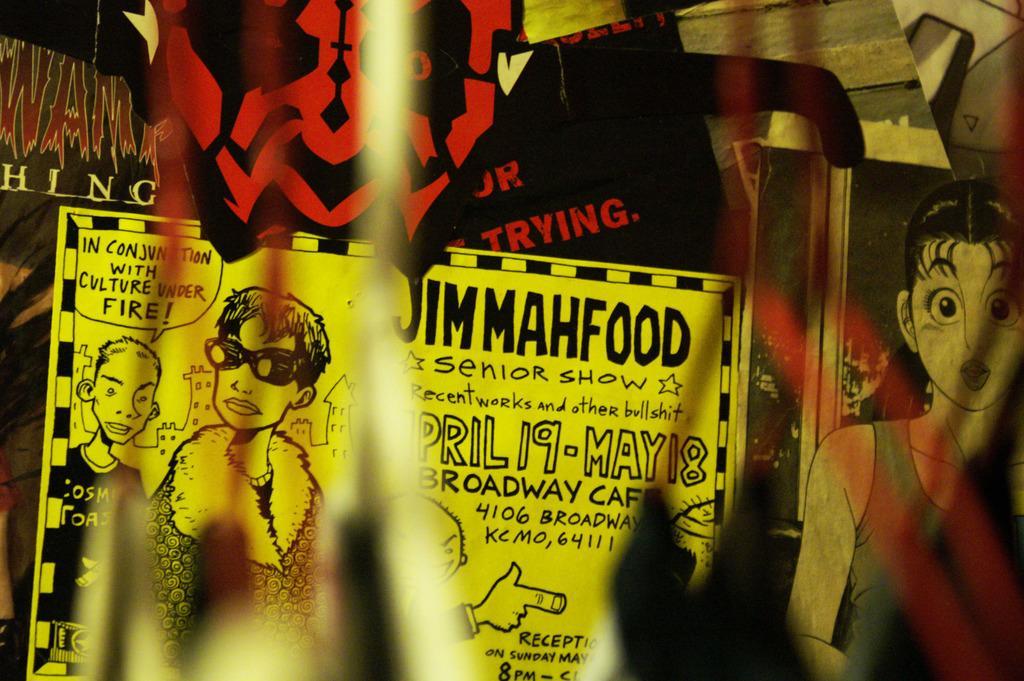Can you describe this image briefly? In the picture I can see a sheet which has few images and something written on it and there are few other images on the wall. 